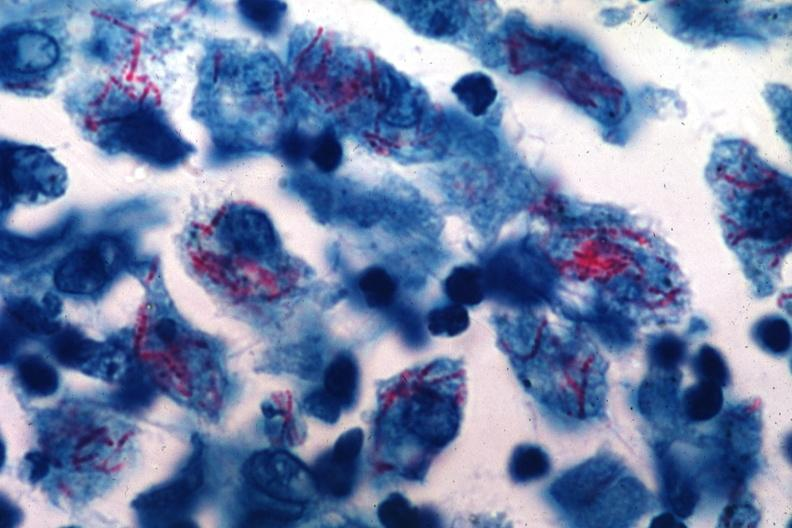s tuberculosis present?
Answer the question using a single word or phrase. Yes 